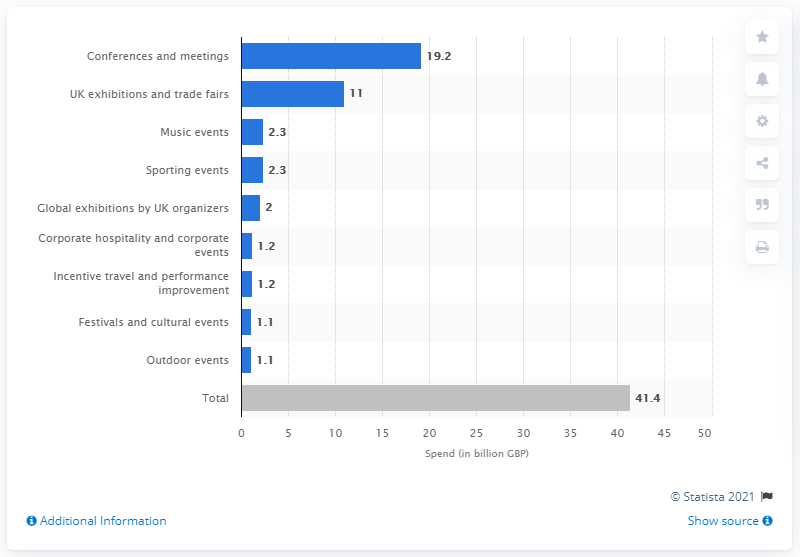I see 'Additional Information' on the chart. Could you provide more details on that? While I can't click on the 'Additional Information' link in the image, it typically would lead to more detailed data or methodology on how the figures were obtained or what they encompass. 